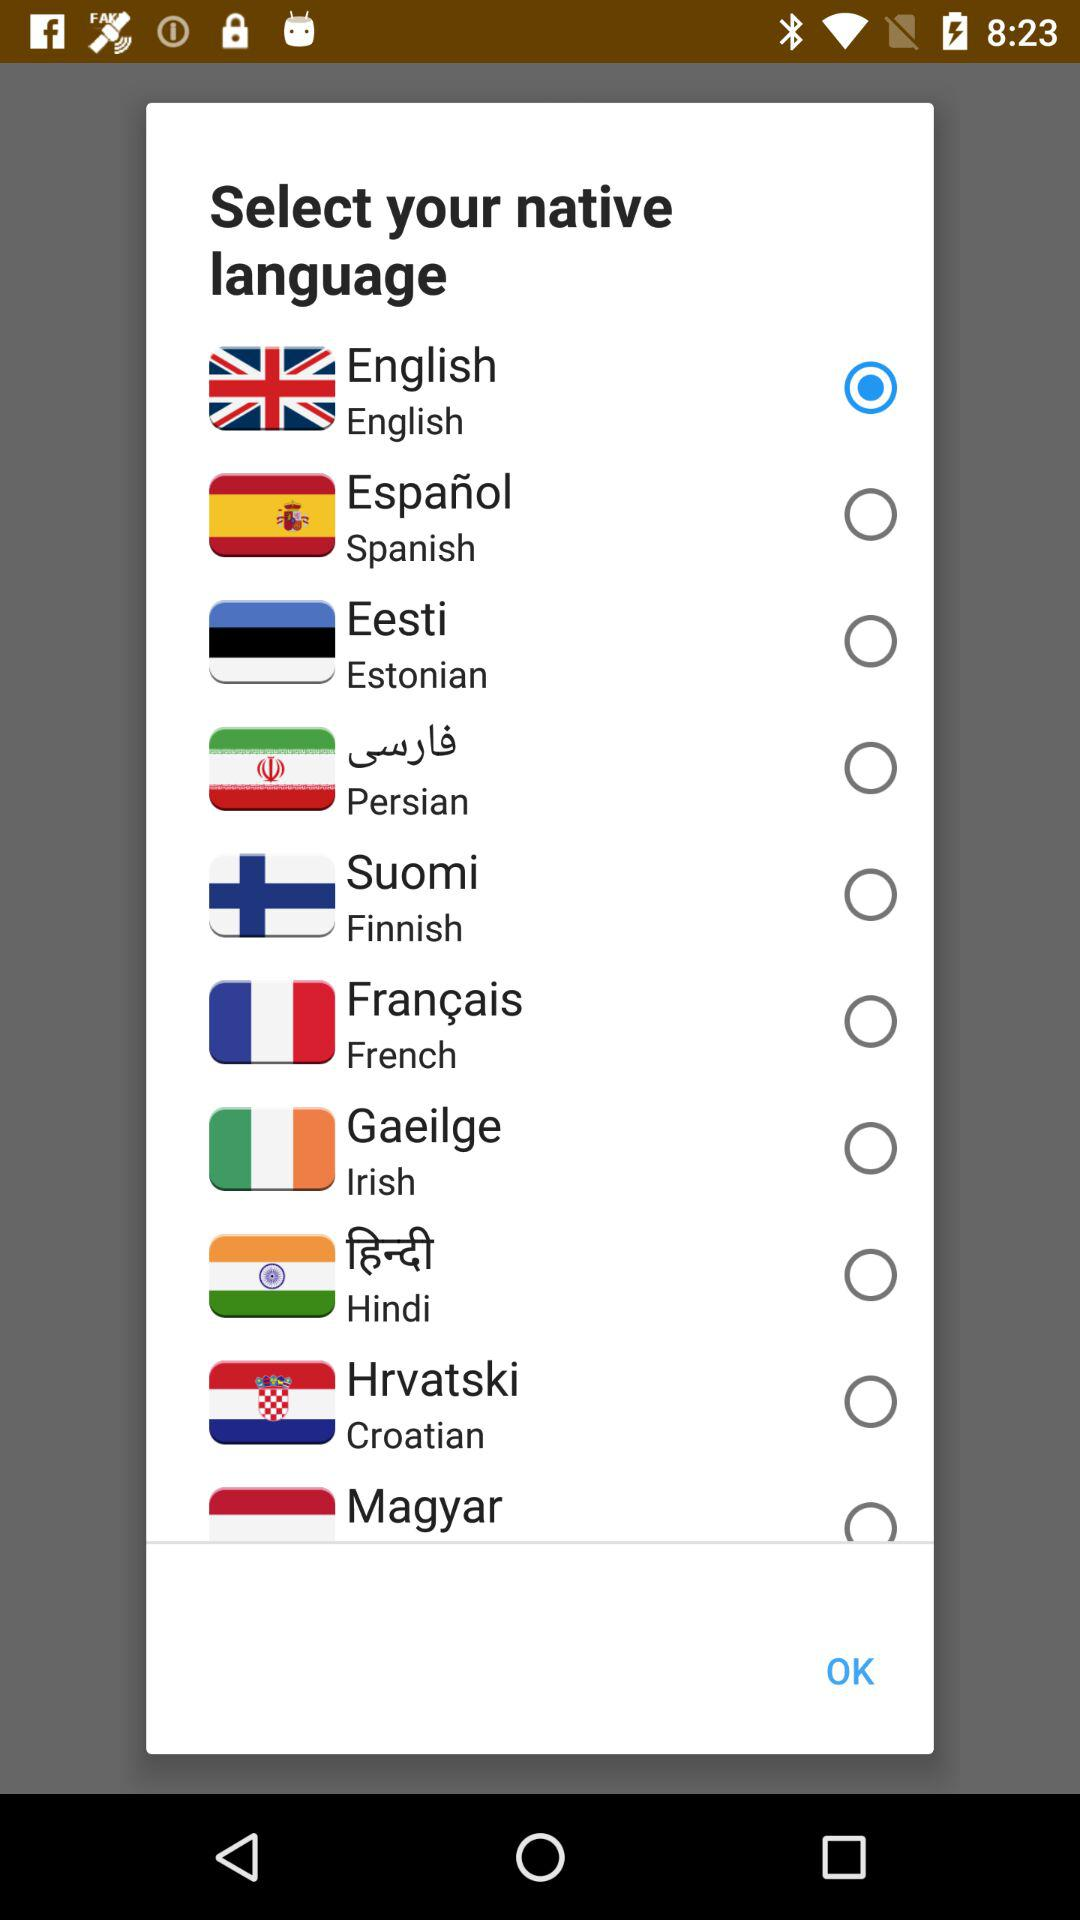How many languages are available to select?
Answer the question using a single word or phrase. 10 